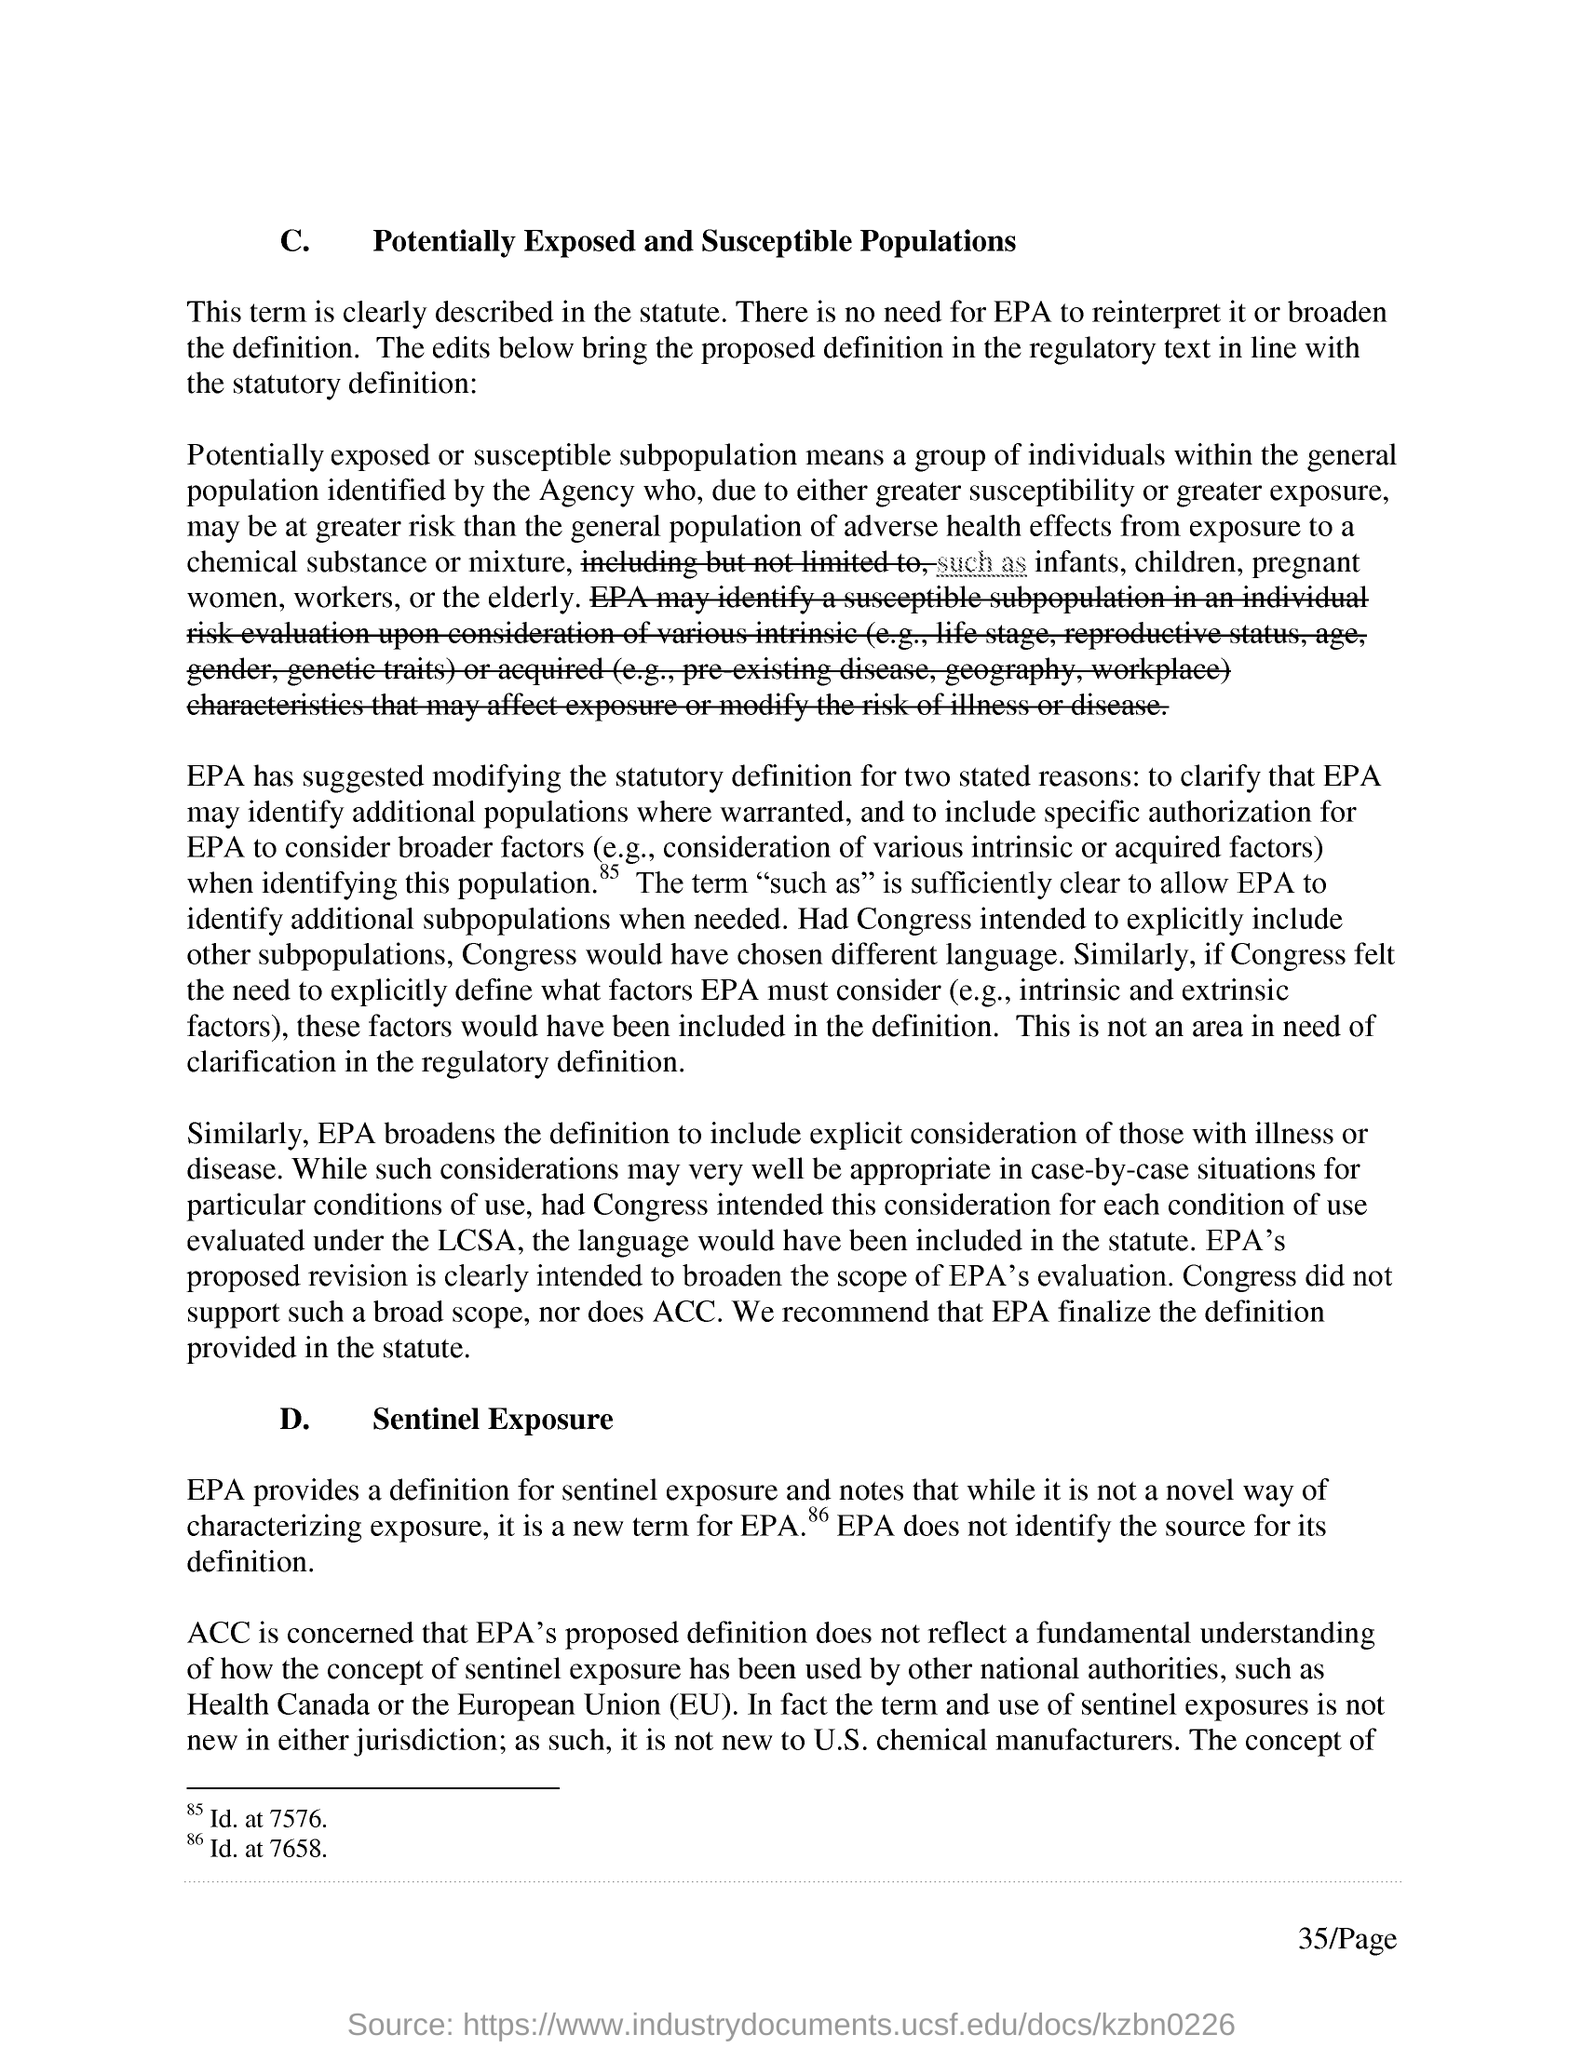Mention a couple of crucial points in this snapshot. The first title in the document is 'Potentially Exposed and Susceptible Populations.' 